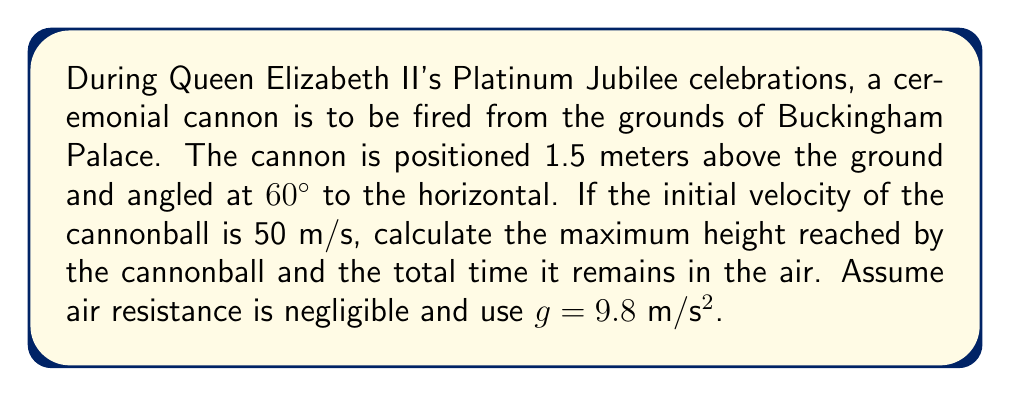Provide a solution to this math problem. Let's approach this problem step-by-step:

1) First, we need to decompose the initial velocity into its vertical and horizontal components:
   $v_{0x} = v_0 \cos \theta = 50 \cos 60° = 25$ m/s
   $v_{0y} = v_0 \sin \theta = 50 \sin 60° = 43.3$ m/s

2) To find the maximum height, we use the equation:
   $$h_{max} = h_0 + \frac{v_{0y}^2}{2g}$$
   where $h_0$ is the initial height (1.5 m)

3) Substituting our values:
   $$h_{max} = 1.5 + \frac{43.3^2}{2(9.8)} = 1.5 + 95.7 = 97.2$$ m

4) To find the total time in the air, we need to calculate the time to reach the maximum height and double it:
   $$t_{up} = \frac{v_{0y}}{g} = \frac{43.3}{9.8} = 4.42$$ s

5) The total time is twice this:
   $$t_{total} = 2 * 4.42 = 8.84$$ s

Therefore, the maximum height reached is 97.2 meters, and the total time in the air is 8.84 seconds.
Answer: Maximum height: 97.2 m; Total time in air: 8.84 s 